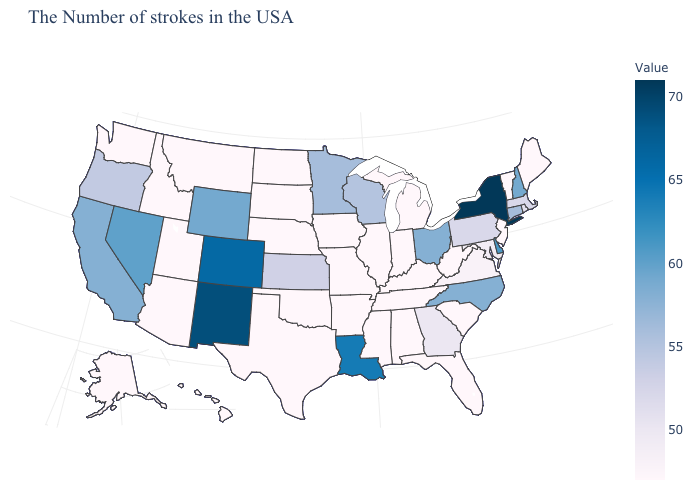Among the states that border Utah , does Nevada have the lowest value?
Be succinct. No. Does the map have missing data?
Answer briefly. No. Among the states that border Delaware , does Pennsylvania have the lowest value?
Answer briefly. No. 